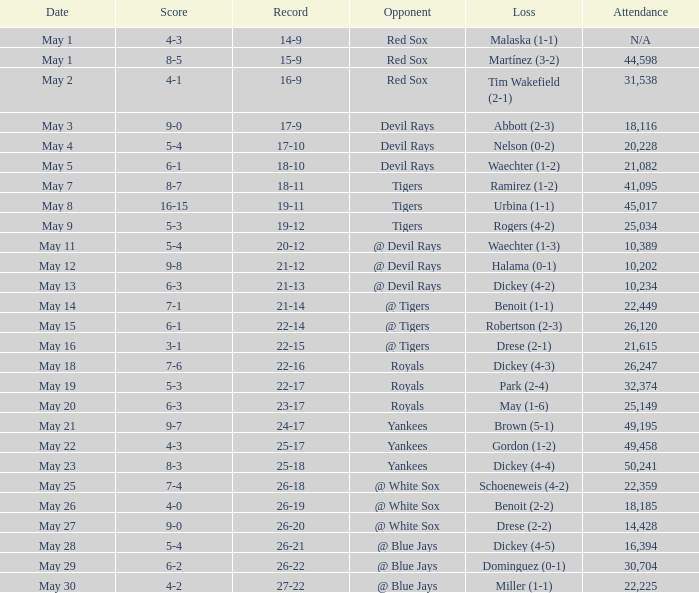What was the score of the game that had a loss of Drese (2-2)? 9-0. 